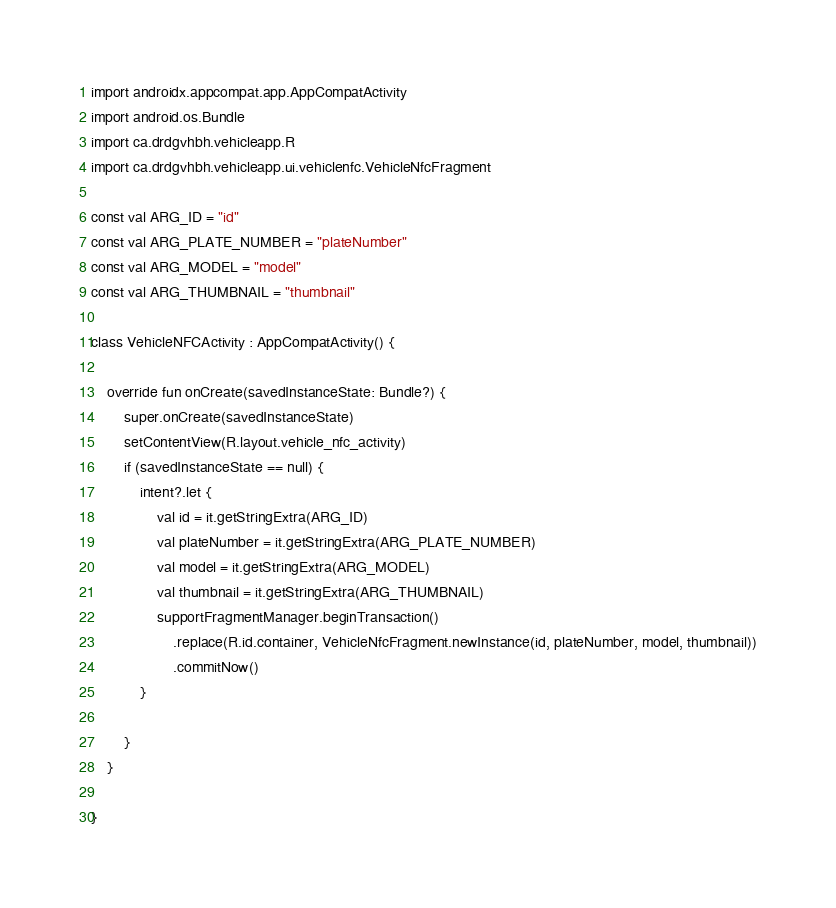Convert code to text. <code><loc_0><loc_0><loc_500><loc_500><_Kotlin_>import androidx.appcompat.app.AppCompatActivity
import android.os.Bundle
import ca.drdgvhbh.vehicleapp.R
import ca.drdgvhbh.vehicleapp.ui.vehiclenfc.VehicleNfcFragment

const val ARG_ID = "id"
const val ARG_PLATE_NUMBER = "plateNumber"
const val ARG_MODEL = "model"
const val ARG_THUMBNAIL = "thumbnail"

class VehicleNFCActivity : AppCompatActivity() {

    override fun onCreate(savedInstanceState: Bundle?) {
        super.onCreate(savedInstanceState)
        setContentView(R.layout.vehicle_nfc_activity)
        if (savedInstanceState == null) {
            intent?.let {
                val id = it.getStringExtra(ARG_ID)
                val plateNumber = it.getStringExtra(ARG_PLATE_NUMBER)
                val model = it.getStringExtra(ARG_MODEL)
                val thumbnail = it.getStringExtra(ARG_THUMBNAIL)
                supportFragmentManager.beginTransaction()
                    .replace(R.id.container, VehicleNfcFragment.newInstance(id, plateNumber, model, thumbnail))
                    .commitNow()
            }

        }
    }

}
</code> 